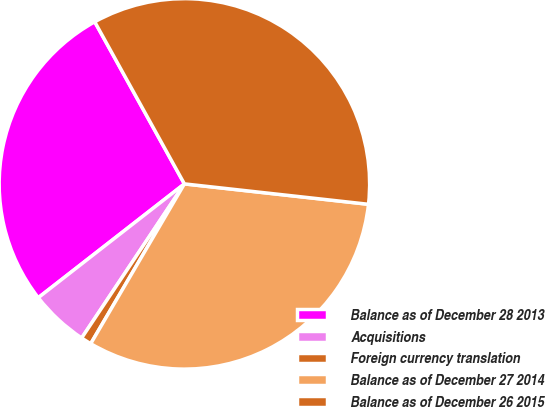<chart> <loc_0><loc_0><loc_500><loc_500><pie_chart><fcel>Balance as of December 28 2013<fcel>Acquisitions<fcel>Foreign currency translation<fcel>Balance as of December 27 2014<fcel>Balance as of December 26 2015<nl><fcel>27.49%<fcel>5.11%<fcel>0.92%<fcel>31.68%<fcel>34.8%<nl></chart> 